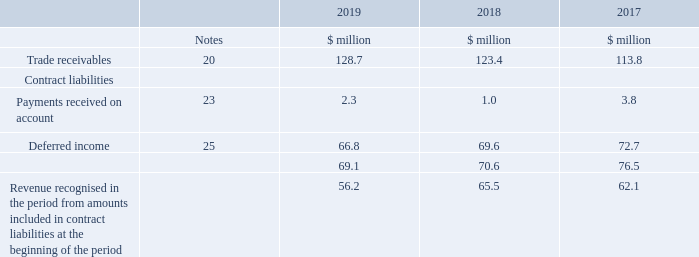29. Contract balances
The following table provides information about receivables and contract liabilities from contracts with customers. The Group does not have any contract assets.
There was no revenue recognised in 2019, 2018 or 2017 from performance obligations satisfied in previous periods.
The timing of revenue recognition, invoicing and cash collections results in trade receivables, deferred income and advance customer payments received on account on the balance sheet.
The Group receives payments from customers based on a billing schedule, as established in the contract. Trade receivables are recognised when the right to consideration becomes unconditional. Contract liabilities are recognised as revenue as (or when) the Group performs under the contract.
The Group also recognises incremental costs incurred to obtain a contract as an asset if it expects to recover those costs. Such costs are presented in the balance sheet as assets recognised from costs to obtain a contract and disclosed in note 21.
When are trade receivables recognised? When the right to consideration becomes unconditional. On what basis does the Group receive payments from customers? Based on a billing schedule, as established in the contract. For which years does the table provide information about receivables and contract liabilities from contracts with customers? 2019, 2018, 2017. In which year was the amount of deferred income the largest? 72.7>69.6>66.8
Answer: 2017. What was the change in trade receivables in 2019 from 2018?
Answer scale should be: million. 128.7-123.4
Answer: 5.3. What was the percentage change in trade receivables in 2019 from 2018?
Answer scale should be: percent. (128.7-123.4)/123.4
Answer: 4.29. 